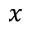<formula> <loc_0><loc_0><loc_500><loc_500>_ { x }</formula> 